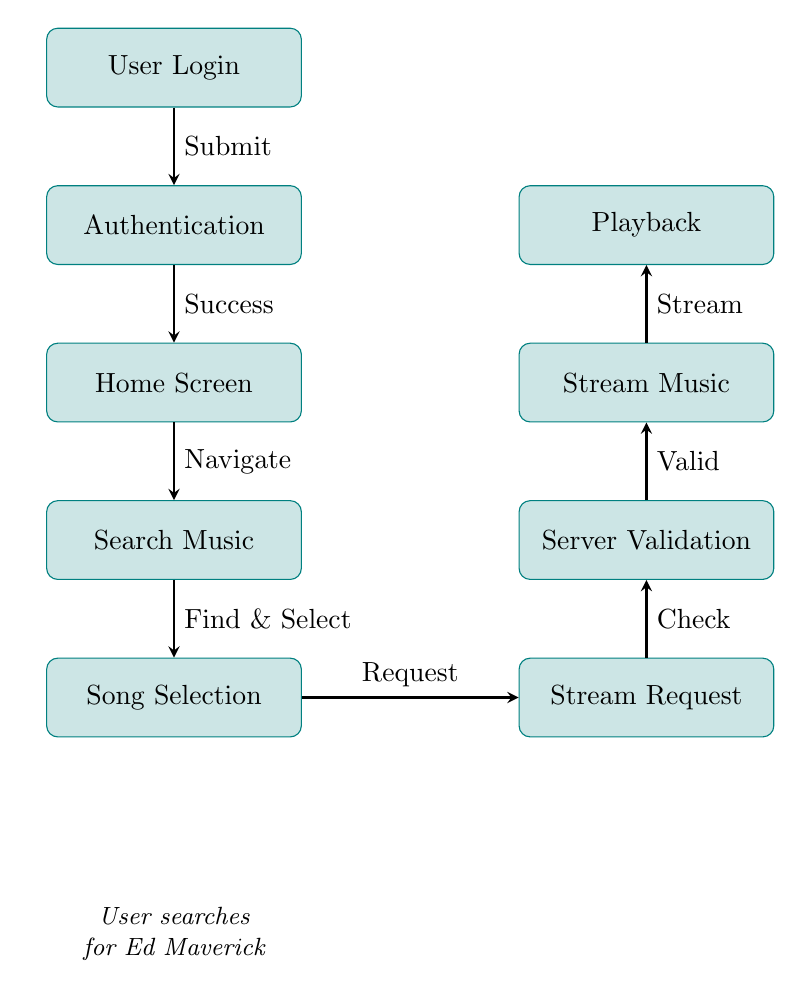What is the first step in the flowchart? The first step shown in the flowchart is "User Login", which is the starting point for the streaming process.
Answer: User Login How many nodes are in the diagram? The diagram contains eight distinct nodes, each representing a process in the streaming workflow from user login to playback.
Answer: 8 What does the user do after authentication? After authentication, the user is taken to the "Home Screen" as the next step in the flowchart.
Answer: Home Screen What action leads to the song selection? The user navigates the "Home Screen" to find music, leading to the action of "Song Selection."
Answer: Navigate Which process comes right before playback? The process that comes right before "Playback" is "Stream Music", which prepares the songs to be played.
Answer: Stream Music What is the relationship between song selection and stream request? The relationship is that after "Song Selection," the user makes a "Stream Request" to begin streaming the selected song.
Answer: Request What step involves server validation? The "Server Validation" step occurs after the "Stream Request" is made, ensuring that the request is valid before streaming.
Answer: Server Validation What does the user search for in the flowchart? The user searches for "Ed Maverick," indicating a specific intent within the diagram's flow.
Answer: Ed Maverick What indicates a successful authentication process? A "Success" label indicates that authentication has been completed successfully, allowing access to the home screen.
Answer: Success 